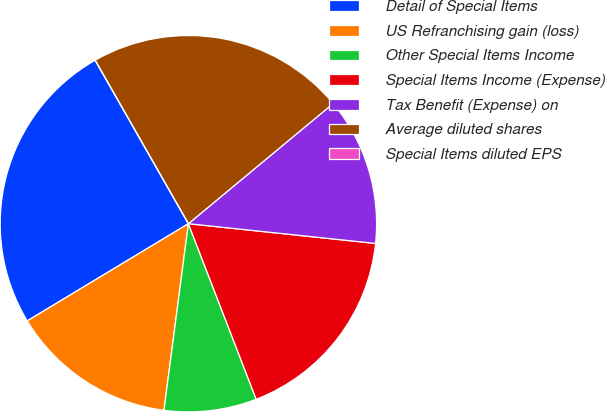<chart> <loc_0><loc_0><loc_500><loc_500><pie_chart><fcel>Detail of Special Items<fcel>US Refranchising gain (loss)<fcel>Other Special Items Income<fcel>Special Items Income (Expense)<fcel>Tax Benefit (Expense) on<fcel>Average diluted shares<fcel>Special Items diluted EPS<nl><fcel>25.39%<fcel>14.29%<fcel>7.94%<fcel>17.46%<fcel>12.7%<fcel>22.22%<fcel>0.0%<nl></chart> 